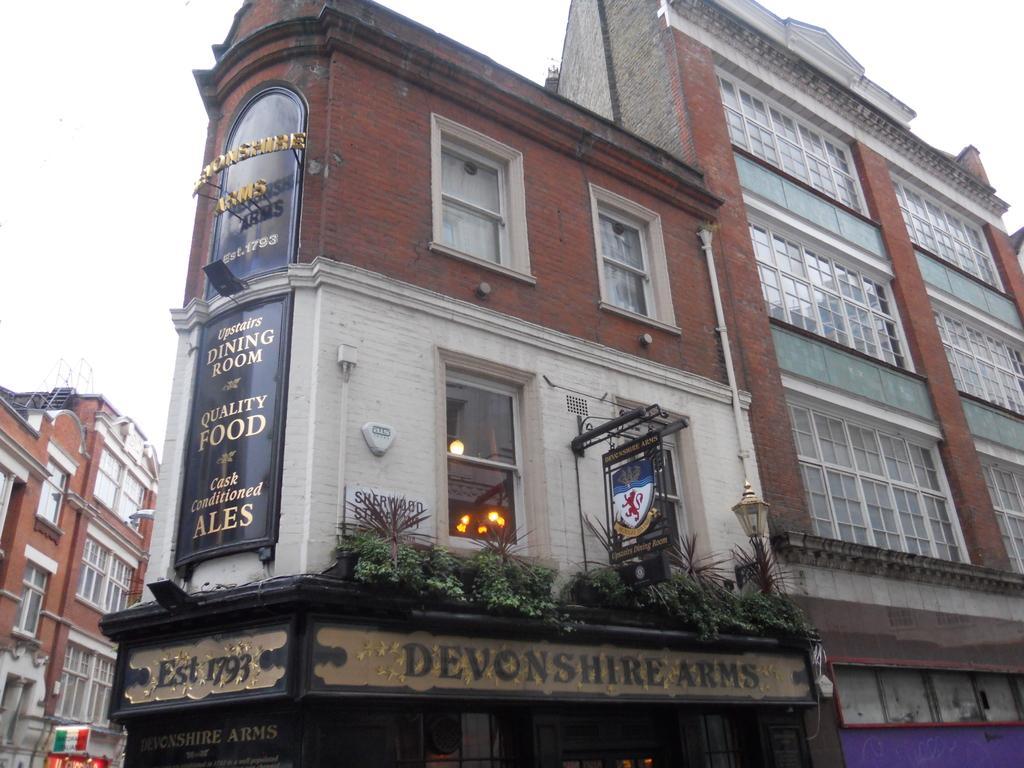In one or two sentences, can you explain what this image depicts? In this picture we can see few buildings, hoardings, lights and plants. 